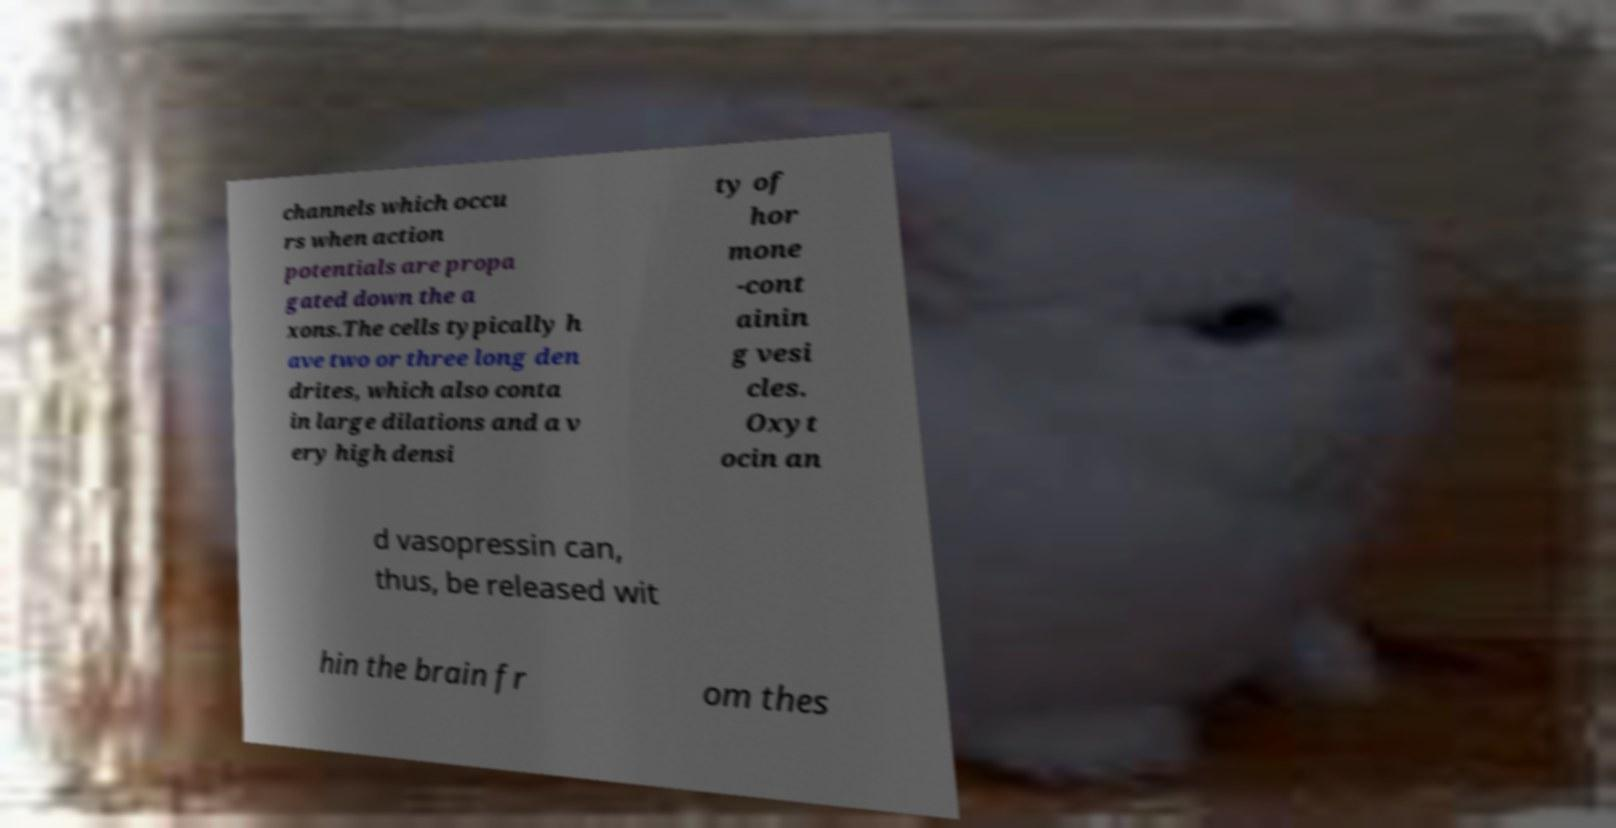Could you extract and type out the text from this image? channels which occu rs when action potentials are propa gated down the a xons.The cells typically h ave two or three long den drites, which also conta in large dilations and a v ery high densi ty of hor mone -cont ainin g vesi cles. Oxyt ocin an d vasopressin can, thus, be released wit hin the brain fr om thes 